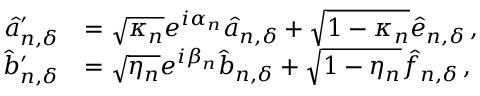Convert formula to latex. <formula><loc_0><loc_0><loc_500><loc_500>\begin{array} { r l } { \hat { a } _ { n , { \delta } } ^ { \prime } } & { = \sqrt { \kappa _ { n } } e ^ { i \alpha _ { n } } \hat { a } _ { n , { \delta } } + \sqrt { 1 - \kappa _ { n } } \hat { e } _ { n , { \delta } } \, , } \\ { \hat { b } _ { n , { \delta } } ^ { \prime } } & { = \sqrt { \eta _ { n } } e ^ { i \beta _ { n } } \hat { b } _ { n , { \delta } } + \sqrt { 1 - \eta _ { n } } \hat { f } _ { n , { \delta } } \, , } \end{array}</formula> 